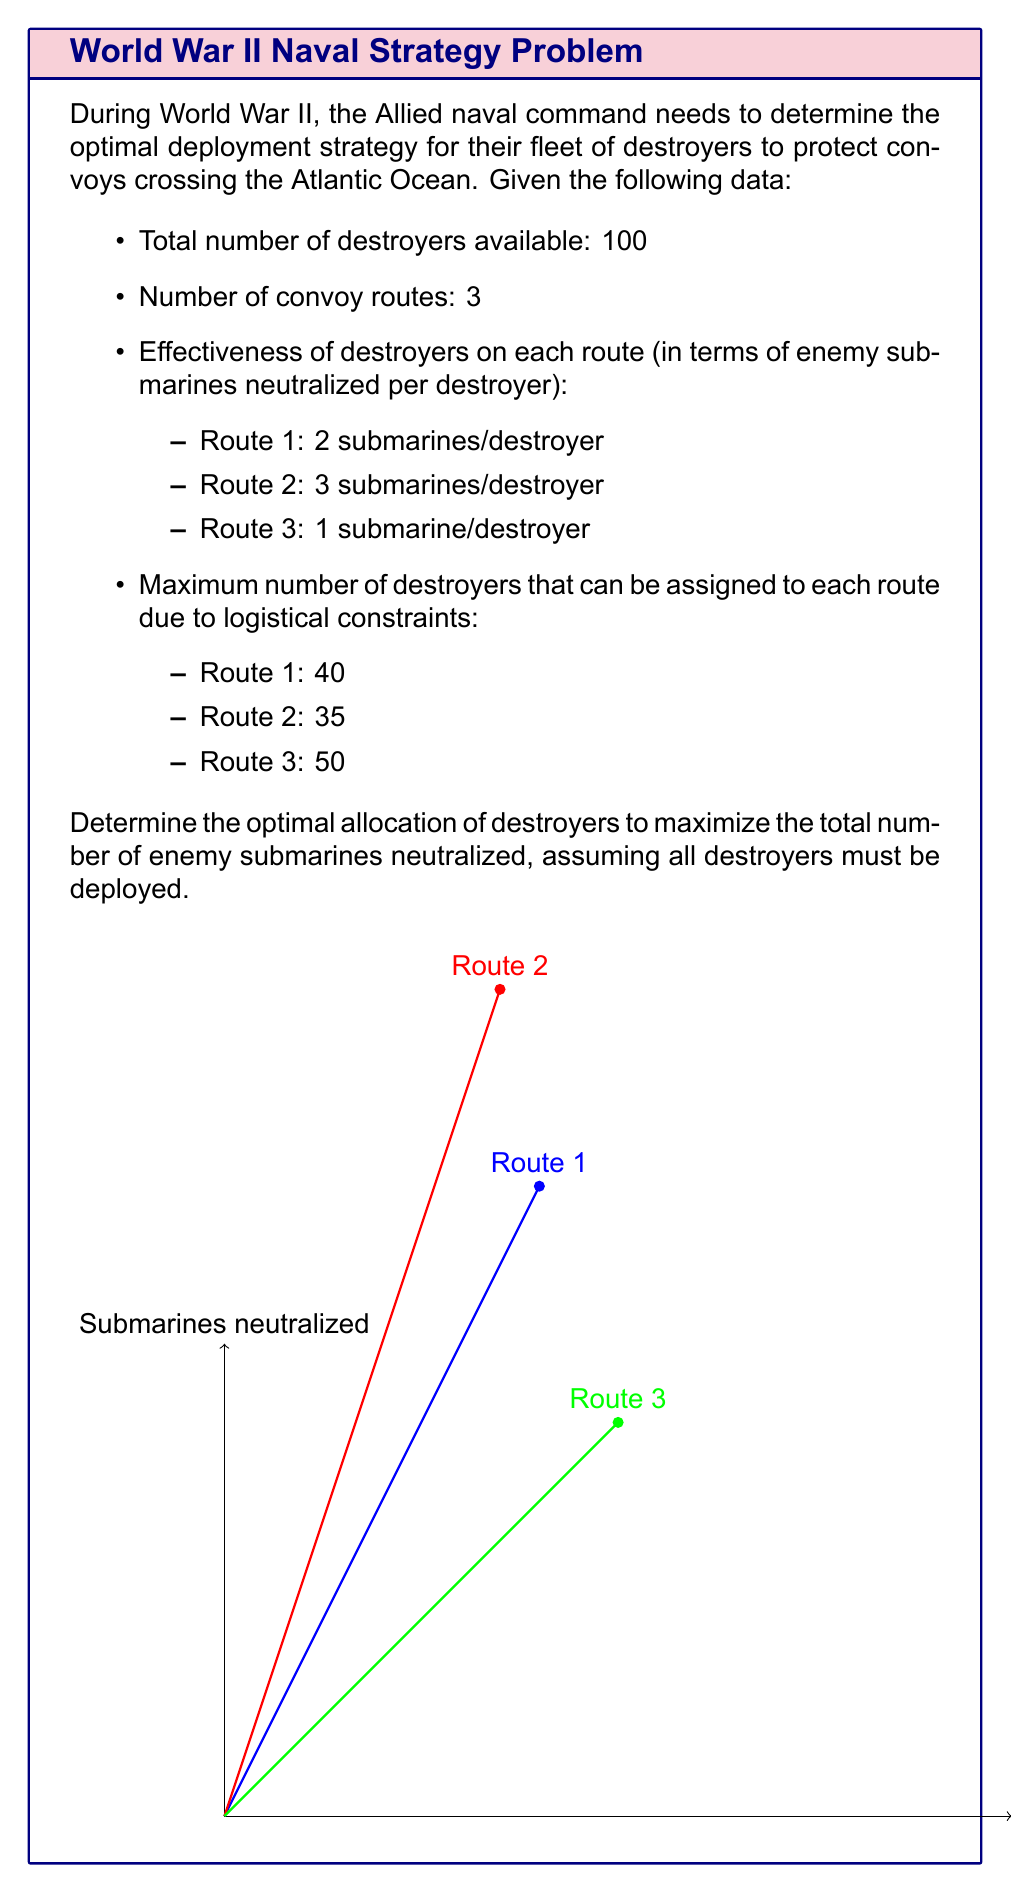Help me with this question. To solve this problem, we'll use linear programming. Let's define our variables:

$x_1$: number of destroyers assigned to Route 1
$x_2$: number of destroyers assigned to Route 2
$x_3$: number of destroyers assigned to Route 3

Our objective function is to maximize the total number of submarines neutralized:

$$\text{Maximize } Z = 2x_1 + 3x_2 + x_3$$

Subject to the following constraints:

1. Total number of destroyers: $x_1 + x_2 + x_3 = 100$
2. Maximum destroyers per route:
   $x_1 \leq 40$
   $x_2 \leq 35$
   $x_3 \leq 50$
3. Non-negativity: $x_1, x_2, x_3 \geq 0$

To solve this, we'll use the following steps:

1. Assign the maximum number of destroyers to the most effective route (Route 2):
   $x_2 = 35$

2. Assign the remaining destroyers to the second most effective route (Route 1) up to its maximum:
   $x_1 = \min(40, 100 - 35) = 40$

3. Assign any remaining destroyers to Route 3:
   $x_3 = 100 - 35 - 40 = 25$

4. Calculate the total number of submarines neutralized:
   $Z = 2(40) + 3(35) + 1(25) = 80 + 105 + 25 = 210$

This solution satisfies all constraints and maximizes the objective function.
Answer: Route 1: 40 destroyers, Route 2: 35 destroyers, Route 3: 25 destroyers; 210 submarines neutralized 